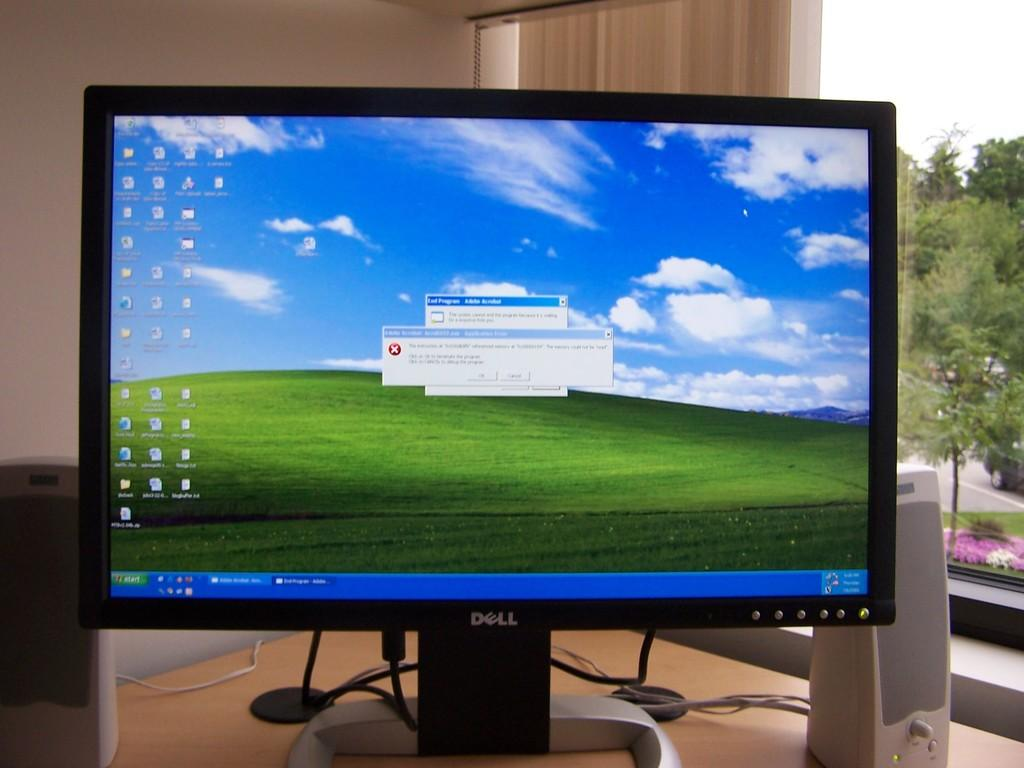<image>
Create a compact narrative representing the image presented. A Dell computer screen is shown displaying an error message. 